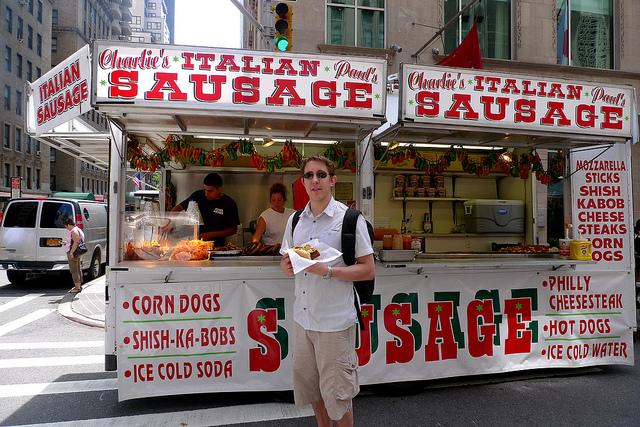Who owns the sausage stand?
Keep it brief. Charlie. What are hot dogs made out of?
Write a very short answer. Italian sausage. What type of food is sold?
Keep it brief. Sausage. Is this market fairly priced?
Give a very brief answer. Yes. How many times does the word "dogs" appear in the image?
Short answer required. 3. 